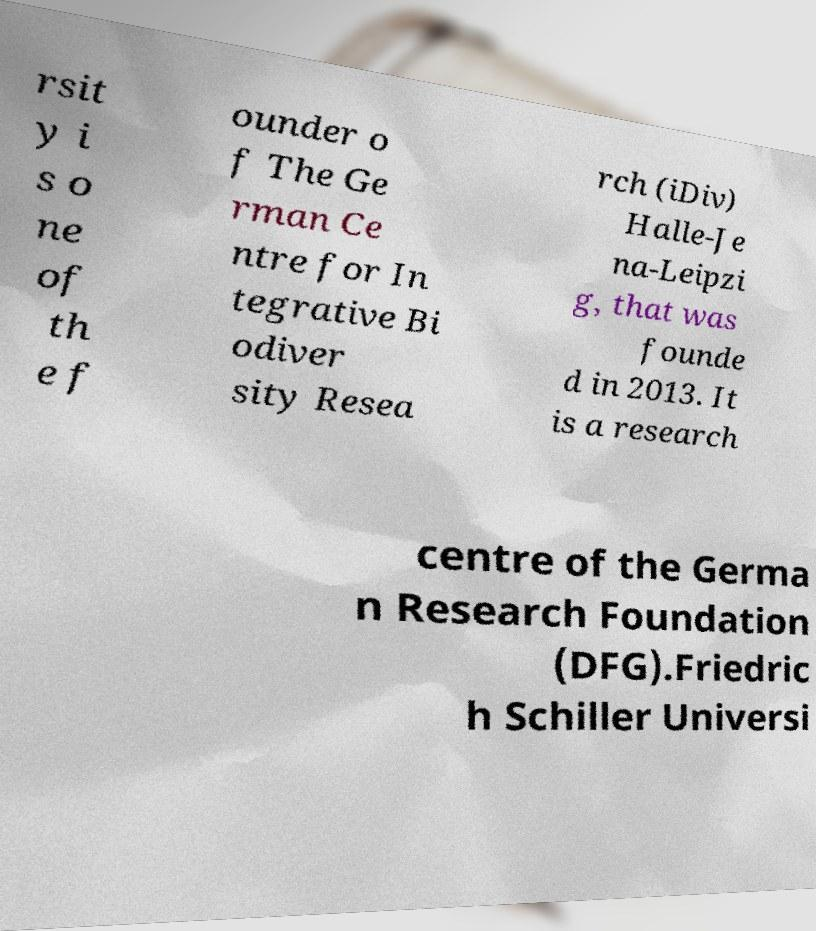Please read and relay the text visible in this image. What does it say? rsit y i s o ne of th e f ounder o f The Ge rman Ce ntre for In tegrative Bi odiver sity Resea rch (iDiv) Halle-Je na-Leipzi g, that was founde d in 2013. It is a research centre of the Germa n Research Foundation (DFG).Friedric h Schiller Universi 